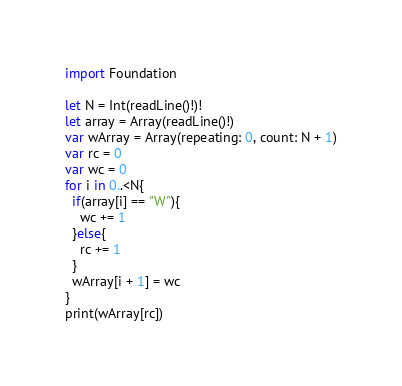<code> <loc_0><loc_0><loc_500><loc_500><_Swift_>import Foundation

let N = Int(readLine()!)!
let array = Array(readLine()!)
var wArray = Array(repeating: 0, count: N + 1)
var rc = 0
var wc = 0
for i in 0..<N{
  if(array[i] == "W"){
    wc += 1
  }else{
    rc += 1
  }
  wArray[i + 1] = wc
}
print(wArray[rc])</code> 